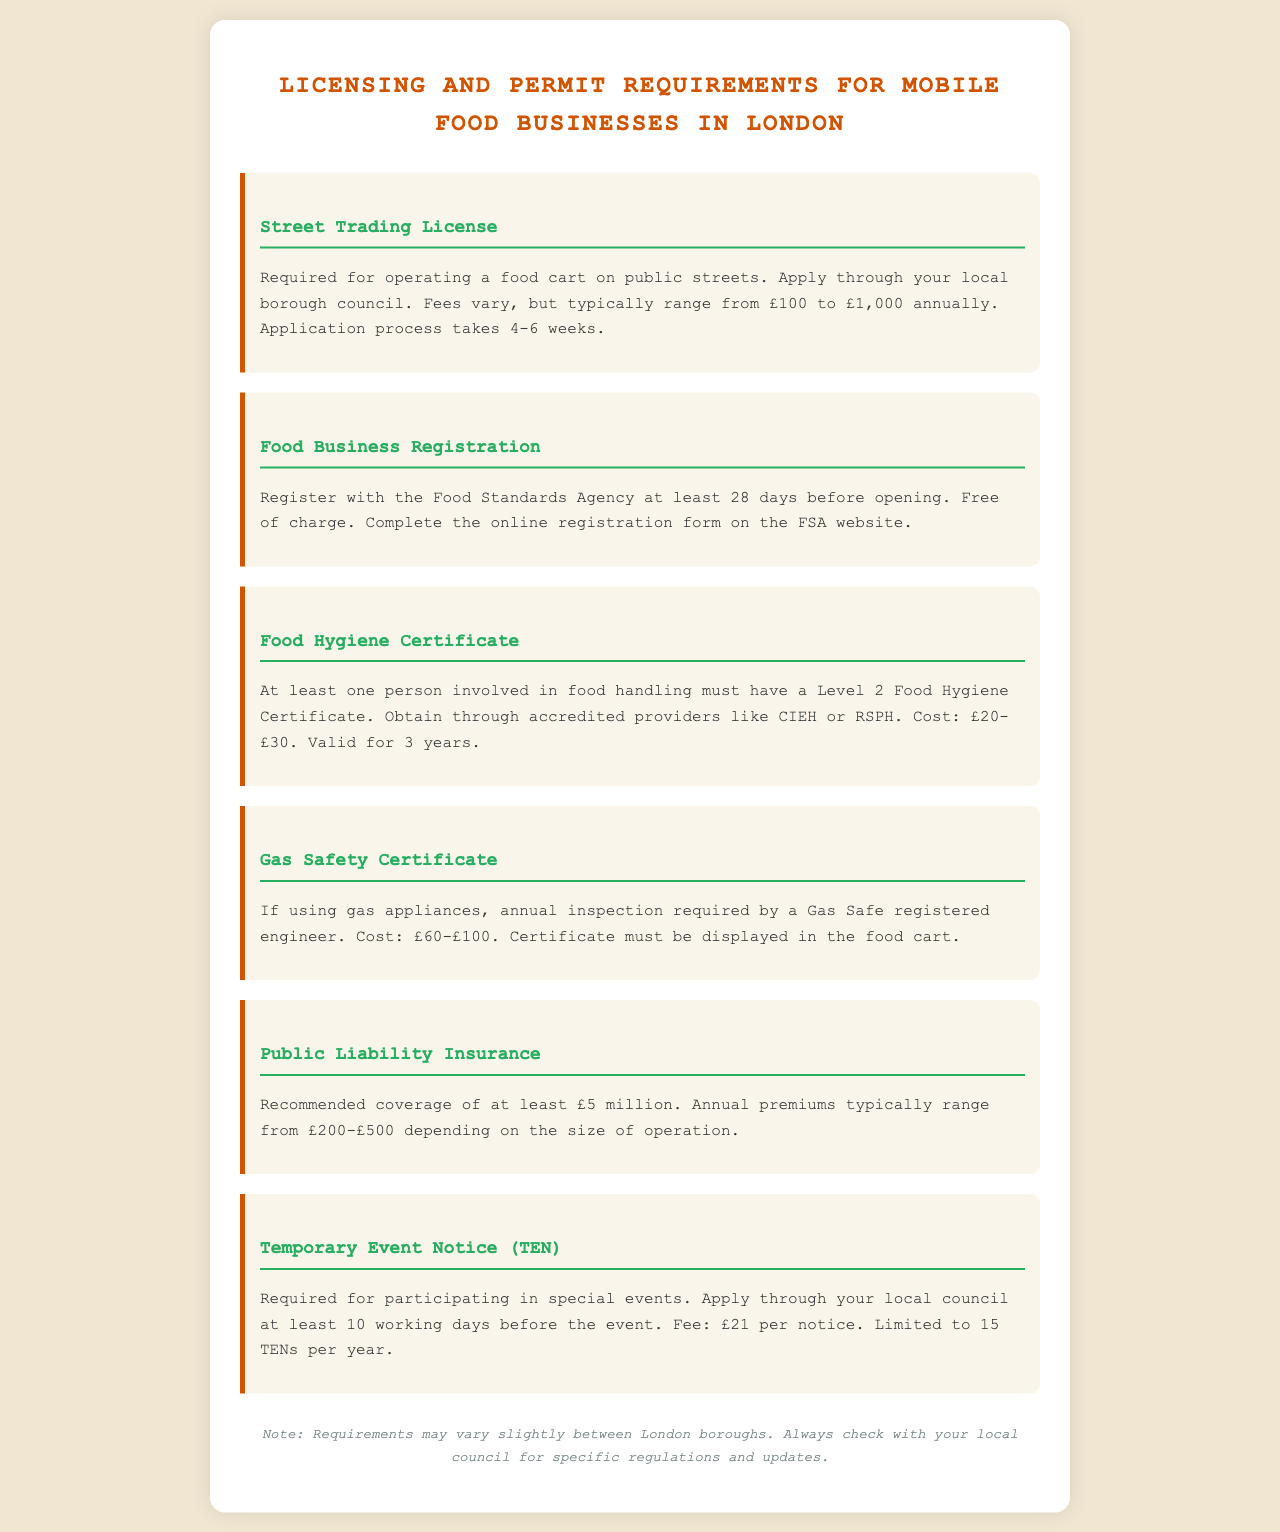what is the fee range for a Street Trading License? The fee range for a Street Trading License is specified in the document as varying from £100 to £1,000 annually.
Answer: £100 to £1,000 how many weeks does the application process for a Street Trading License typically take? The application process for a Street Trading License typically takes 4-6 weeks as mentioned in the document.
Answer: 4-6 weeks what is the cost range for obtaining a Food Hygiene Certificate? The document provides a cost range for obtaining a Food Hygiene Certificate, which is £20-£30.
Answer: £20-£30 how many Temporary Event Notices can a mobile food business apply for in a year? According to the document, a mobile food business is limited to 15 Temporary Event Notices per year.
Answer: 15 how far in advance must you apply for a Temporary Event Notice? The document states that you must apply for a Temporary Event Notice at least 10 working days before the event.
Answer: 10 working days what is the recommended coverage amount for Public Liability Insurance? The recommended coverage amount for Public Liability Insurance, as stated in the document, is at least £5 million.
Answer: £5 million who should you register your food business with? The document indicates that you should register your food business with the Food Standards Agency.
Answer: Food Standards Agency what must be displayed in the food cart if gas appliances are used? The document specifies that a Gas Safety Certificate must be displayed in the food cart if gas appliances are used.
Answer: Gas Safety Certificate 